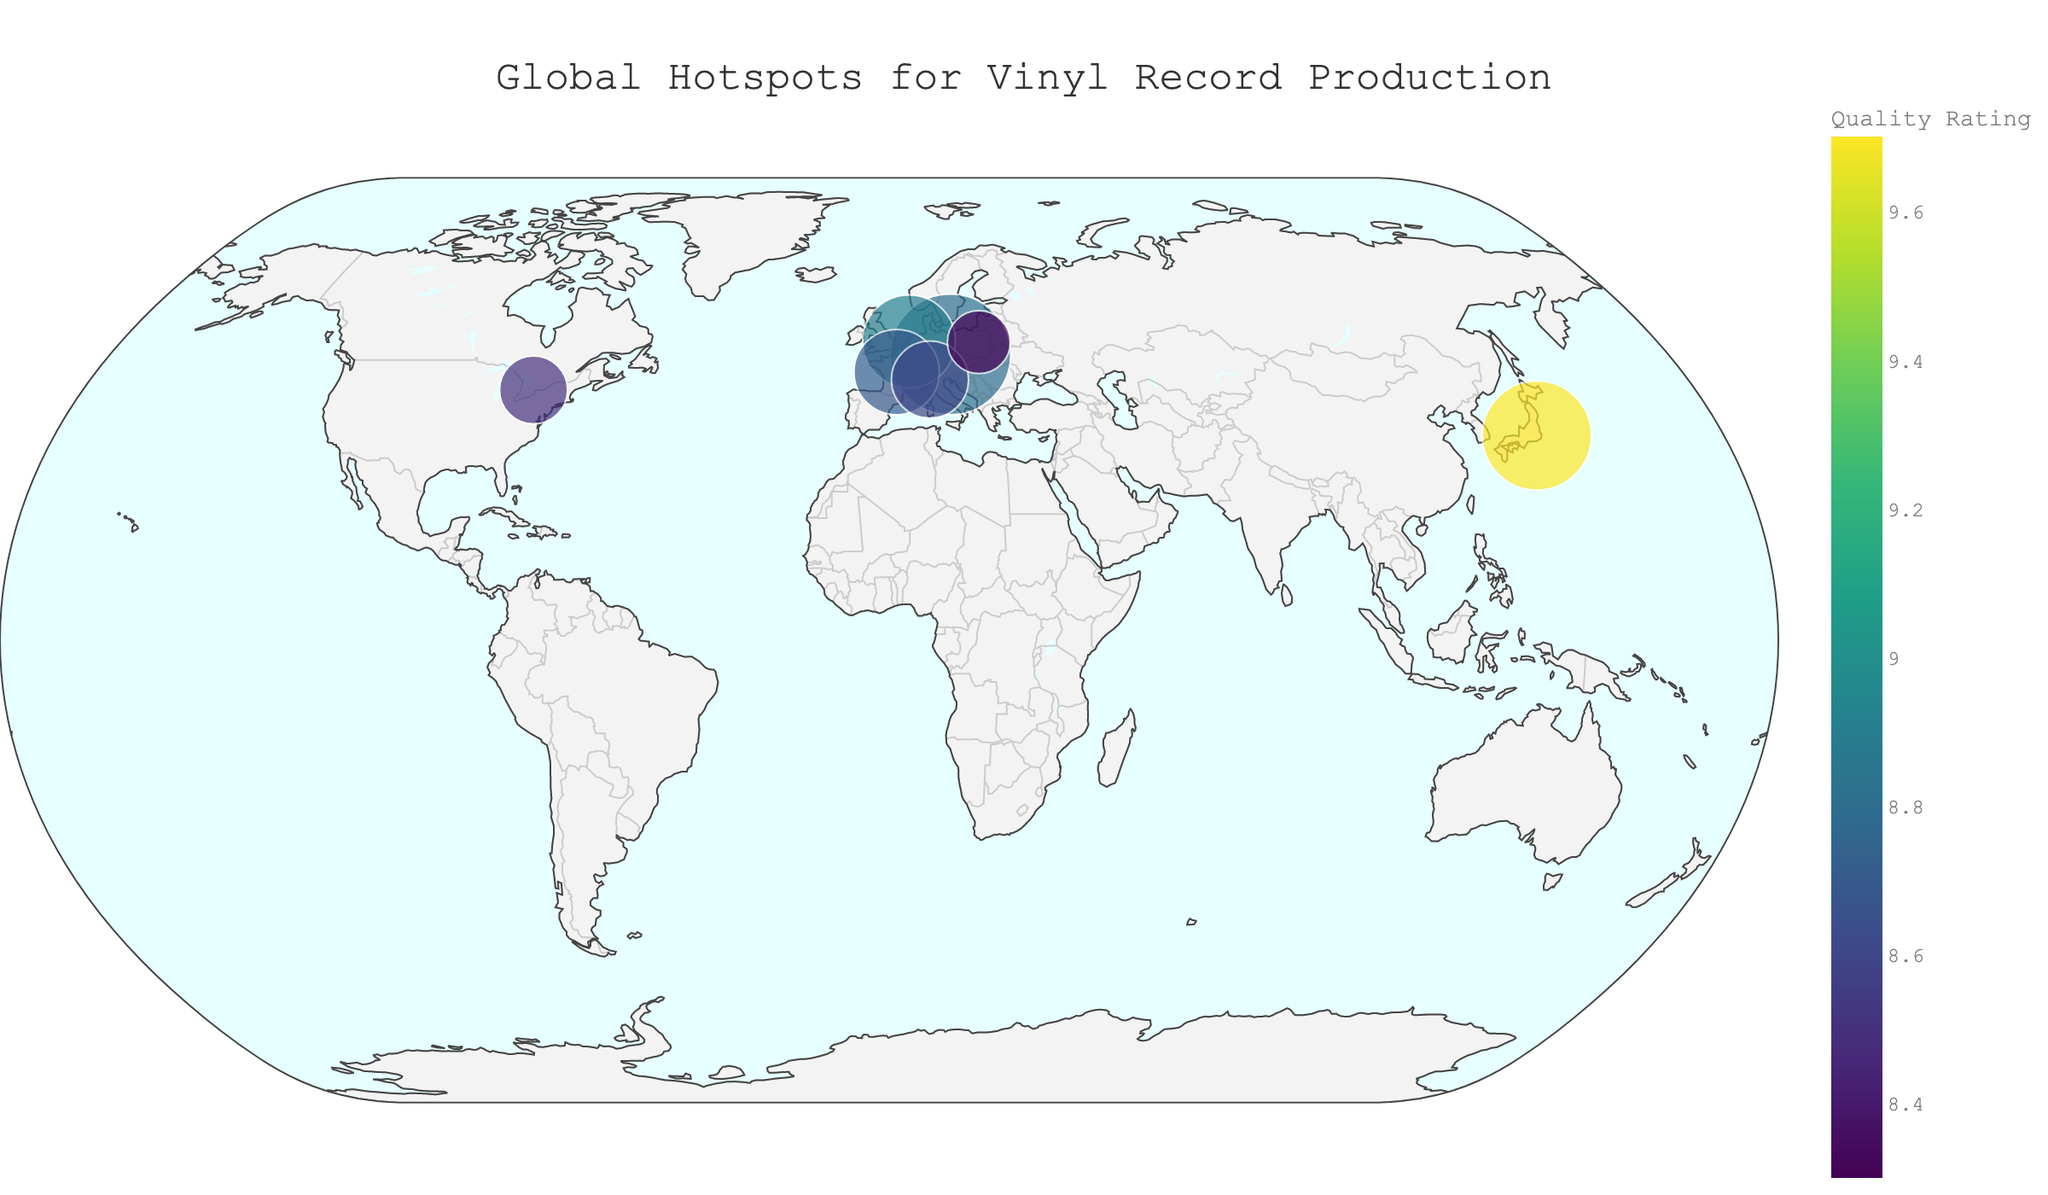What is the title of the plot? The title of the plot is displayed prominently at the top.
Answer: Global Hotspots for Vinyl Record Production How many cities are shown on the map? By counting the number of data points on the map.
Answer: 7 Which city has the highest quality rating? Look for the city with the highest value in the color range associated with "Quality Rating".
Answer: Tokyo What is the production volume of the notable label in Toronto? Refer to the hover data for Toronto, which shows "Production Volume".
Answer: 70,000 Which cities have a production volume greater than 100,000? Identify cities with marker sizes indicating production volumes greater than 100,000.
Answer: Lodenice, Tokyo, Haarlem, Châteauroux What is the difference in production volume between Tokyo and Warsaw? The production volume of Tokyo is 180,000 and that of Warsaw is 60,000. The difference is calculated as 180,000 - 60,000.
Answer: 120,000 What do the colors on the plot represent? The colors of the markers represent the "Quality Rating".
Answer: Quality Rating List all the notable labels mentioned in the plot. Hover over each data point to see the labels given in the "Notable Labels" data field.
Answer: GZ Media, Sony Music Communications, Record Industry, MPO, Vinyl Magic, Precision Record Pressing, WM Fono Which city has the smallest production volume, and what is it? Look for the smallest marker on the plot and check the production volume in the hover data.
Answer: Warsaw, 60,000 How does the plot visually differentiate between cities with different production volumes? The plot uses the size of the markers to represent varying production volumes. Larger markers indicate higher production volumes.
Answer: Marker size 